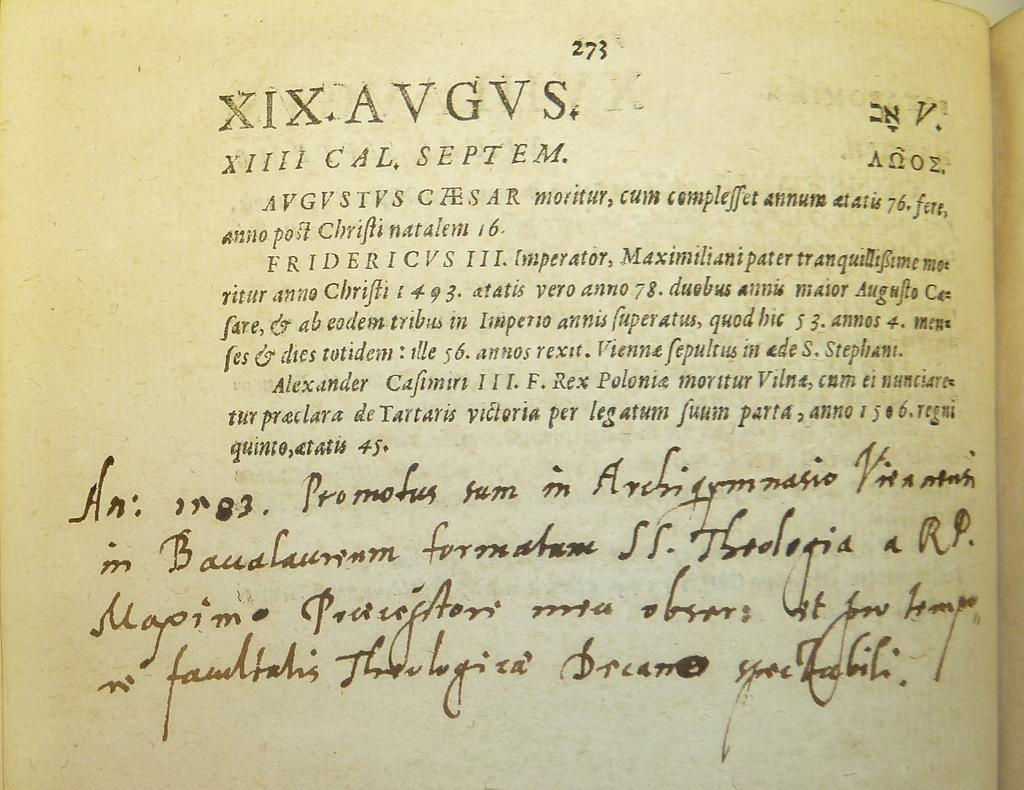<image>
Describe the image concisely. Page 273 of a book with both handwritten and printed text on it. 